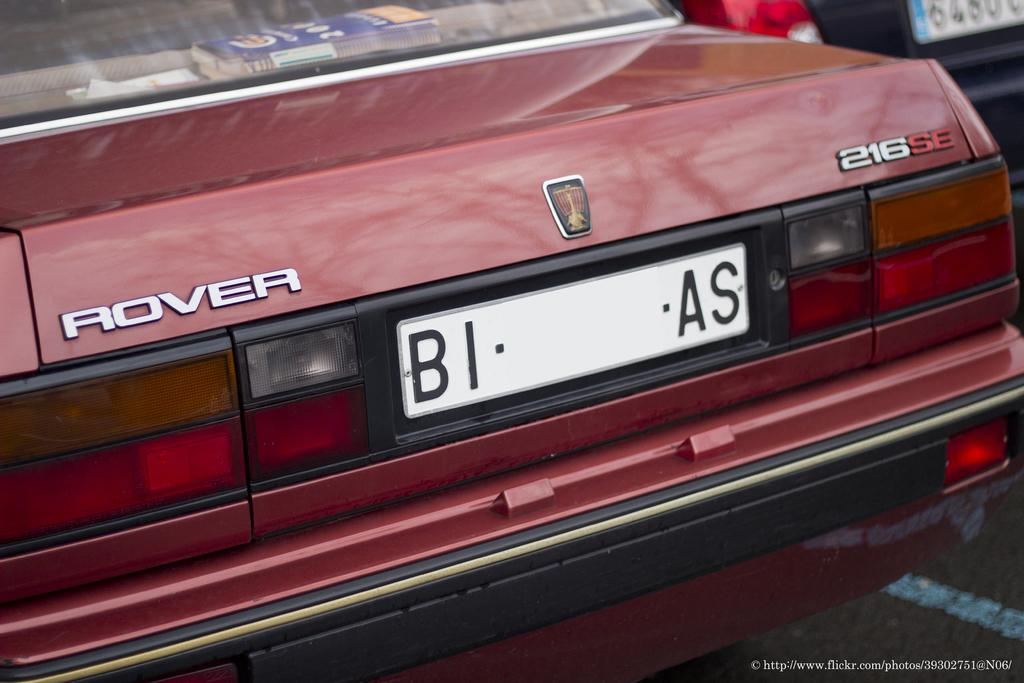What is present in the image that has wheels? There are vehicles in the image that have wheels. How are the vehicles positioned in the image? The vehicles are facing away from the viewer. What can be seen on the vehicles in the image? There are name plates on the vehicles in the image. What is written at the bottom of the image? There is text at the bottom of the image. What type of whip is being used to comfort the animals in the image? There is no whip or animals present in the image. What type of home is visible in the image? There is no home visible in the image; it features vehicles and name plates. 